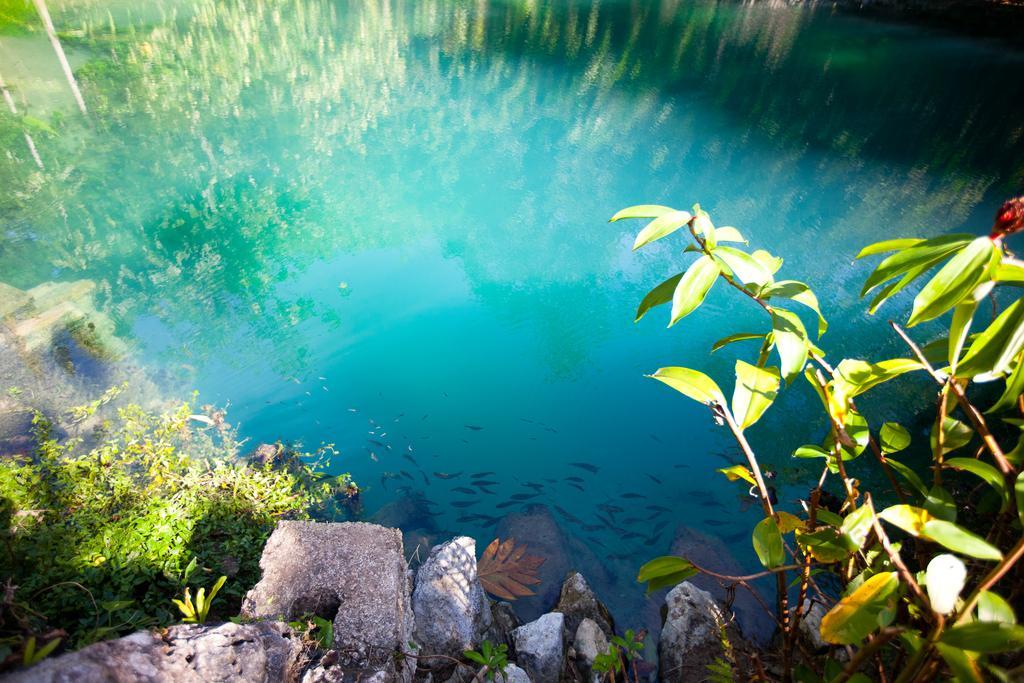How would you summarize this image in a sentence or two? In this image there are rocks, plants, grass and a few small fish in the water. 